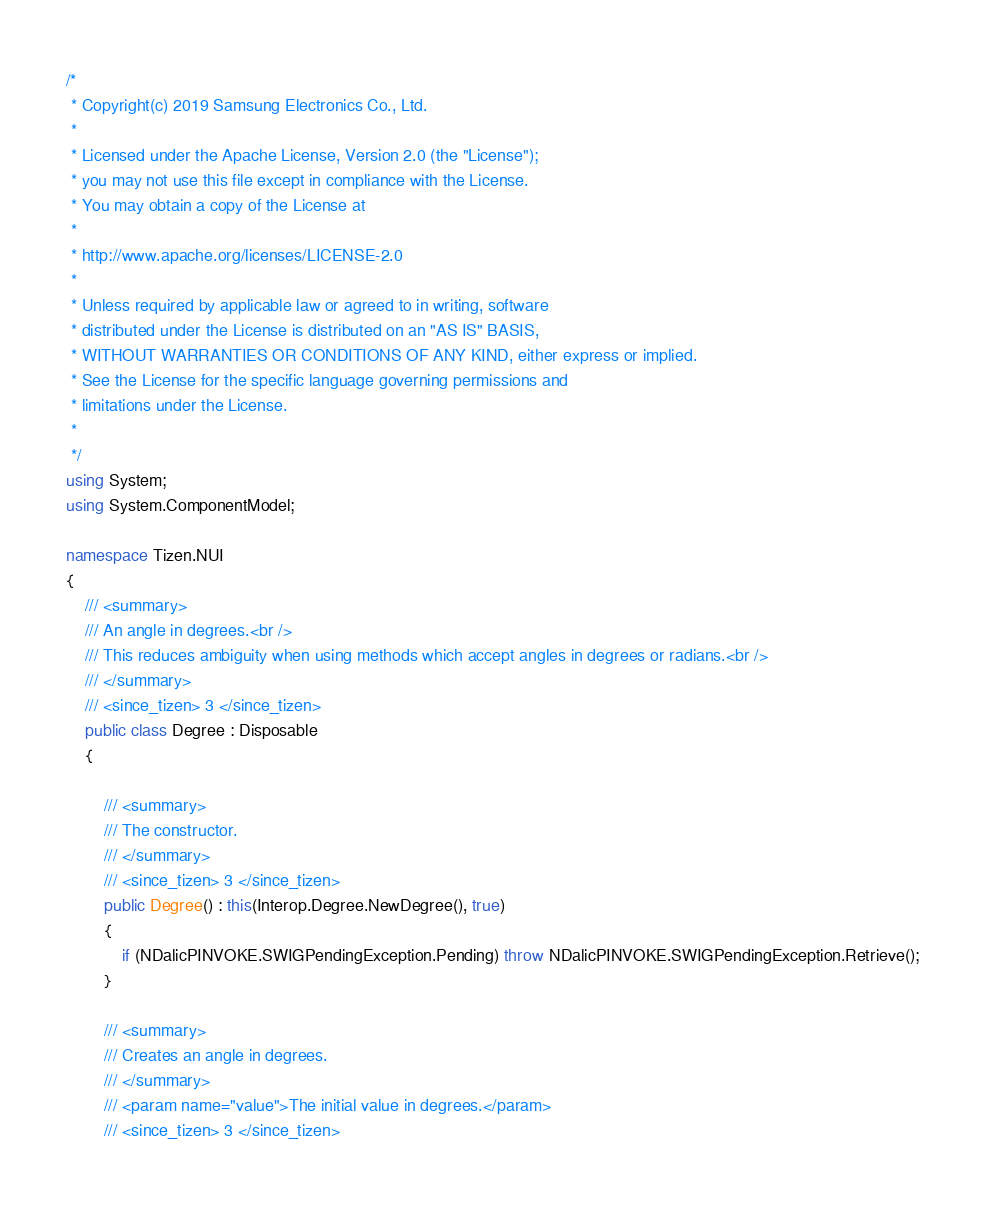<code> <loc_0><loc_0><loc_500><loc_500><_C#_>/*
 * Copyright(c) 2019 Samsung Electronics Co., Ltd.
 *
 * Licensed under the Apache License, Version 2.0 (the "License");
 * you may not use this file except in compliance with the License.
 * You may obtain a copy of the License at
 *
 * http://www.apache.org/licenses/LICENSE-2.0
 *
 * Unless required by applicable law or agreed to in writing, software
 * distributed under the License is distributed on an "AS IS" BASIS,
 * WITHOUT WARRANTIES OR CONDITIONS OF ANY KIND, either express or implied.
 * See the License for the specific language governing permissions and
 * limitations under the License.
 *
 */
using System;
using System.ComponentModel;

namespace Tizen.NUI
{
    /// <summary>
    /// An angle in degrees.<br />
    /// This reduces ambiguity when using methods which accept angles in degrees or radians.<br />
    /// </summary>
    /// <since_tizen> 3 </since_tizen>
    public class Degree : Disposable
    {

        /// <summary>
        /// The constructor.
        /// </summary>
        /// <since_tizen> 3 </since_tizen>
        public Degree() : this(Interop.Degree.NewDegree(), true)
        {
            if (NDalicPINVOKE.SWIGPendingException.Pending) throw NDalicPINVOKE.SWIGPendingException.Retrieve();
        }

        /// <summary>
        /// Creates an angle in degrees.
        /// </summary>
        /// <param name="value">The initial value in degrees.</param>
        /// <since_tizen> 3 </since_tizen></code> 